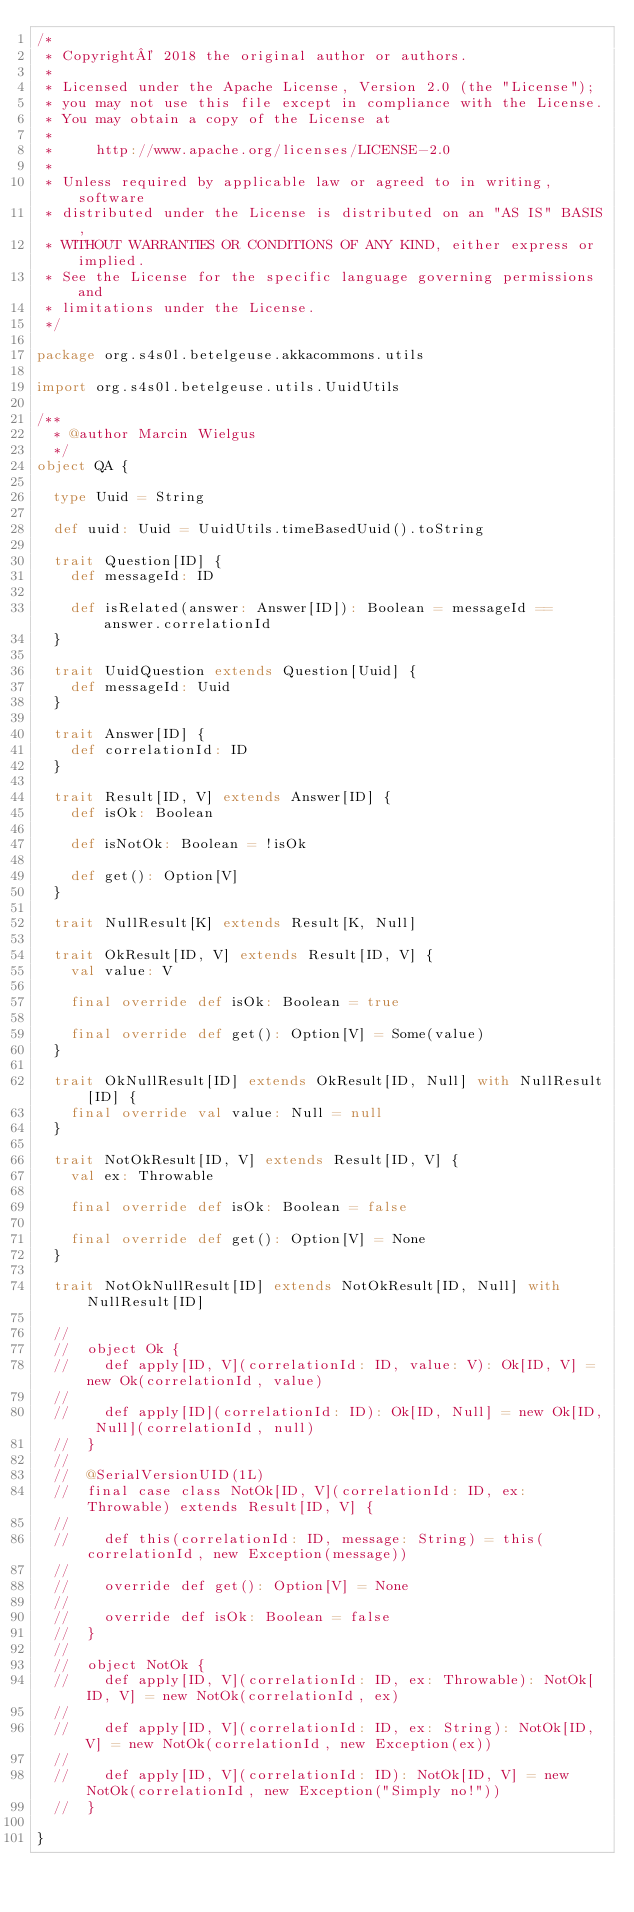Convert code to text. <code><loc_0><loc_0><loc_500><loc_500><_Scala_>/*
 * Copyright© 2018 the original author or authors.
 *
 * Licensed under the Apache License, Version 2.0 (the "License");
 * you may not use this file except in compliance with the License.
 * You may obtain a copy of the License at
 *
 *     http://www.apache.org/licenses/LICENSE-2.0
 *
 * Unless required by applicable law or agreed to in writing, software
 * distributed under the License is distributed on an "AS IS" BASIS,
 * WITHOUT WARRANTIES OR CONDITIONS OF ANY KIND, either express or implied.
 * See the License for the specific language governing permissions and
 * limitations under the License.
 */

package org.s4s0l.betelgeuse.akkacommons.utils

import org.s4s0l.betelgeuse.utils.UuidUtils

/**
  * @author Marcin Wielgus
  */
object QA {

  type Uuid = String

  def uuid: Uuid = UuidUtils.timeBasedUuid().toString

  trait Question[ID] {
    def messageId: ID

    def isRelated(answer: Answer[ID]): Boolean = messageId == answer.correlationId
  }

  trait UuidQuestion extends Question[Uuid] {
    def messageId: Uuid
  }

  trait Answer[ID] {
    def correlationId: ID
  }

  trait Result[ID, V] extends Answer[ID] {
    def isOk: Boolean

    def isNotOk: Boolean = !isOk

    def get(): Option[V]
  }

  trait NullResult[K] extends Result[K, Null]

  trait OkResult[ID, V] extends Result[ID, V] {
    val value: V

    final override def isOk: Boolean = true

    final override def get(): Option[V] = Some(value)
  }

  trait OkNullResult[ID] extends OkResult[ID, Null] with NullResult[ID] {
    final override val value: Null = null
  }

  trait NotOkResult[ID, V] extends Result[ID, V] {
    val ex: Throwable

    final override def isOk: Boolean = false

    final override def get(): Option[V] = None
  }

  trait NotOkNullResult[ID] extends NotOkResult[ID, Null] with NullResult[ID]

  //
  //  object Ok {
  //    def apply[ID, V](correlationId: ID, value: V): Ok[ID, V] = new Ok(correlationId, value)
  //
  //    def apply[ID](correlationId: ID): Ok[ID, Null] = new Ok[ID, Null](correlationId, null)
  //  }
  //
  //  @SerialVersionUID(1L)
  //  final case class NotOk[ID, V](correlationId: ID, ex: Throwable) extends Result[ID, V] {
  //
  //    def this(correlationId: ID, message: String) = this(correlationId, new Exception(message))
  //
  //    override def get(): Option[V] = None
  //
  //    override def isOk: Boolean = false
  //  }
  //
  //  object NotOk {
  //    def apply[ID, V](correlationId: ID, ex: Throwable): NotOk[ID, V] = new NotOk(correlationId, ex)
  //
  //    def apply[ID, V](correlationId: ID, ex: String): NotOk[ID, V] = new NotOk(correlationId, new Exception(ex))
  //
  //    def apply[ID, V](correlationId: ID): NotOk[ID, V] = new NotOk(correlationId, new Exception("Simply no!"))
  //  }

}
</code> 